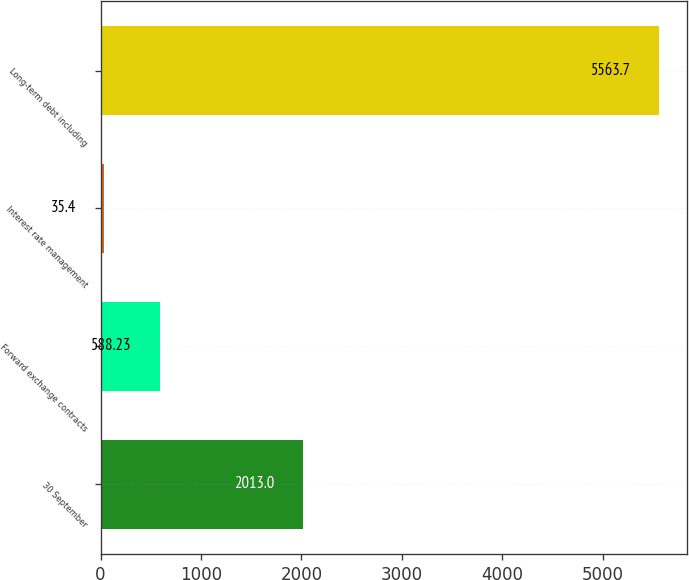Convert chart. <chart><loc_0><loc_0><loc_500><loc_500><bar_chart><fcel>30 September<fcel>Forward exchange contracts<fcel>Interest rate management<fcel>Long-term debt including<nl><fcel>2013<fcel>588.23<fcel>35.4<fcel>5563.7<nl></chart> 